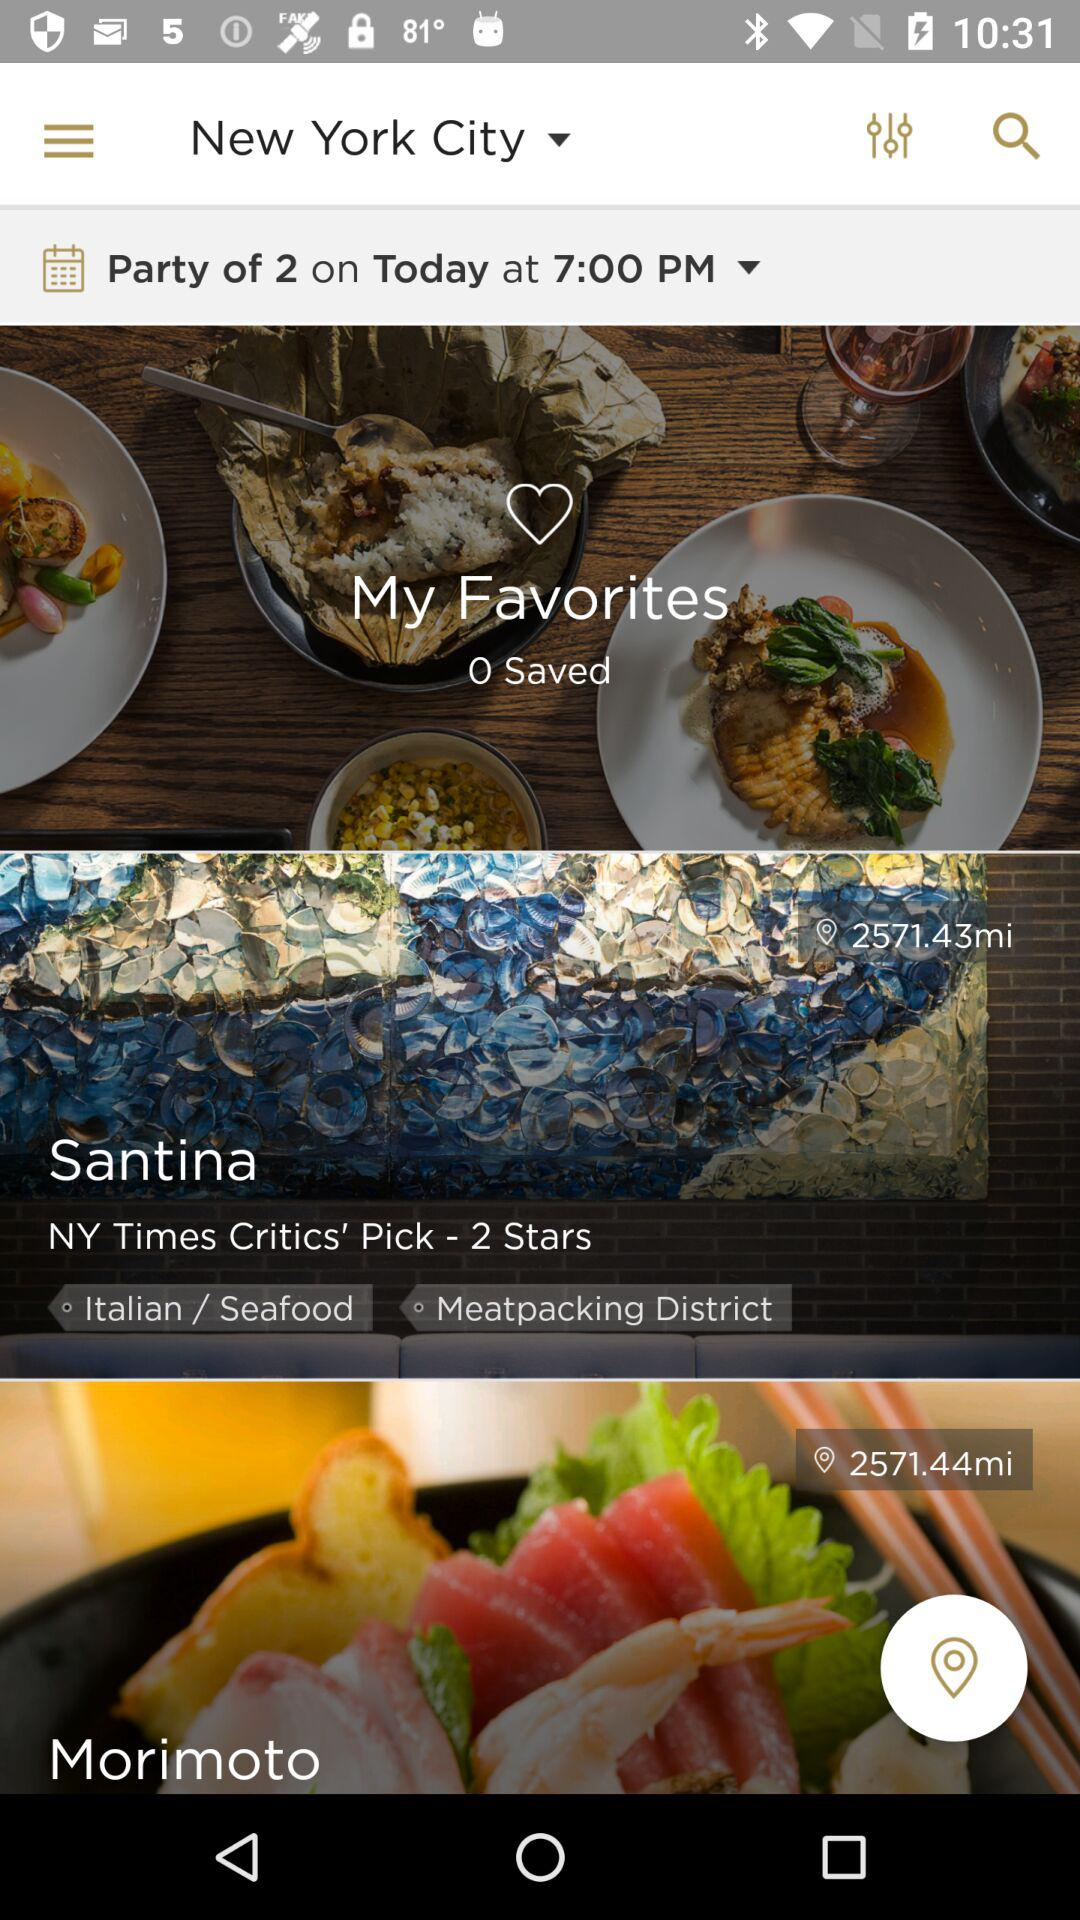What is the number of My Favorites?
When the provided information is insufficient, respond with <no answer>. <no answer> 